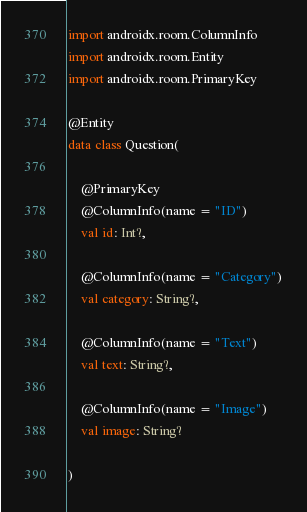Convert code to text. <code><loc_0><loc_0><loc_500><loc_500><_Kotlin_>import androidx.room.ColumnInfo
import androidx.room.Entity
import androidx.room.PrimaryKey

@Entity
data class Question(

    @PrimaryKey
    @ColumnInfo(name = "ID")
    val id: Int?,

    @ColumnInfo(name = "Category")
    val category: String?,

    @ColumnInfo(name = "Text")
    val text: String?,

    @ColumnInfo(name = "Image")
    val image: String?

)
</code> 